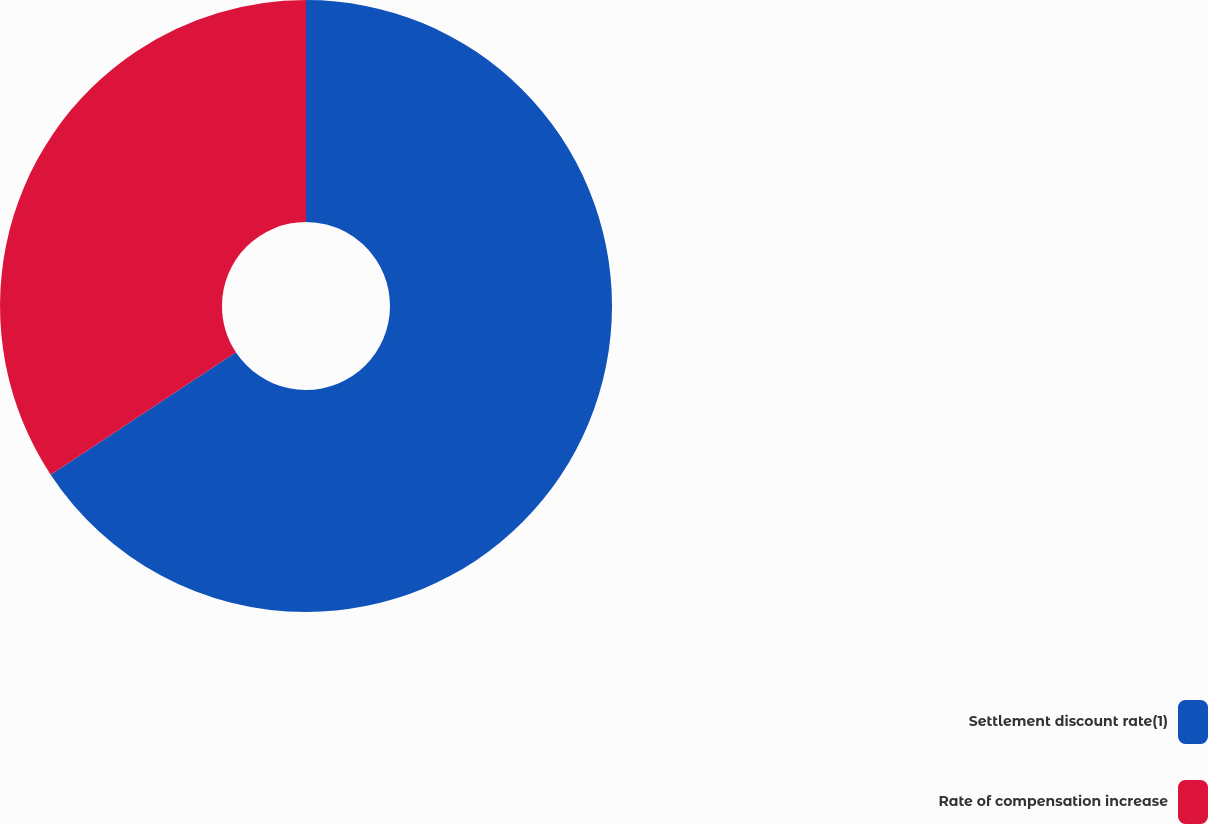Convert chart. <chart><loc_0><loc_0><loc_500><loc_500><pie_chart><fcel>Settlement discount rate(1)<fcel>Rate of compensation increase<nl><fcel>65.71%<fcel>34.29%<nl></chart> 